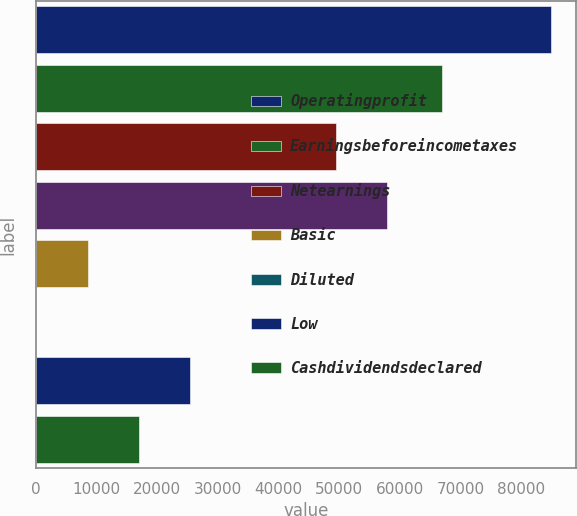<chart> <loc_0><loc_0><loc_500><loc_500><bar_chart><fcel>Operatingprofit<fcel>Earningsbeforeincometaxes<fcel>Netearnings<fcel>Unnamed: 3<fcel>Basic<fcel>Diluted<fcel>Low<fcel>Cashdividendsdeclared<nl><fcel>84874<fcel>67020<fcel>49419<fcel>57906.4<fcel>8487.77<fcel>0.41<fcel>25462.5<fcel>16975.1<nl></chart> 